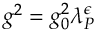<formula> <loc_0><loc_0><loc_500><loc_500>g ^ { 2 } = g _ { 0 } ^ { 2 } \lambda _ { P } ^ { \epsilon }</formula> 